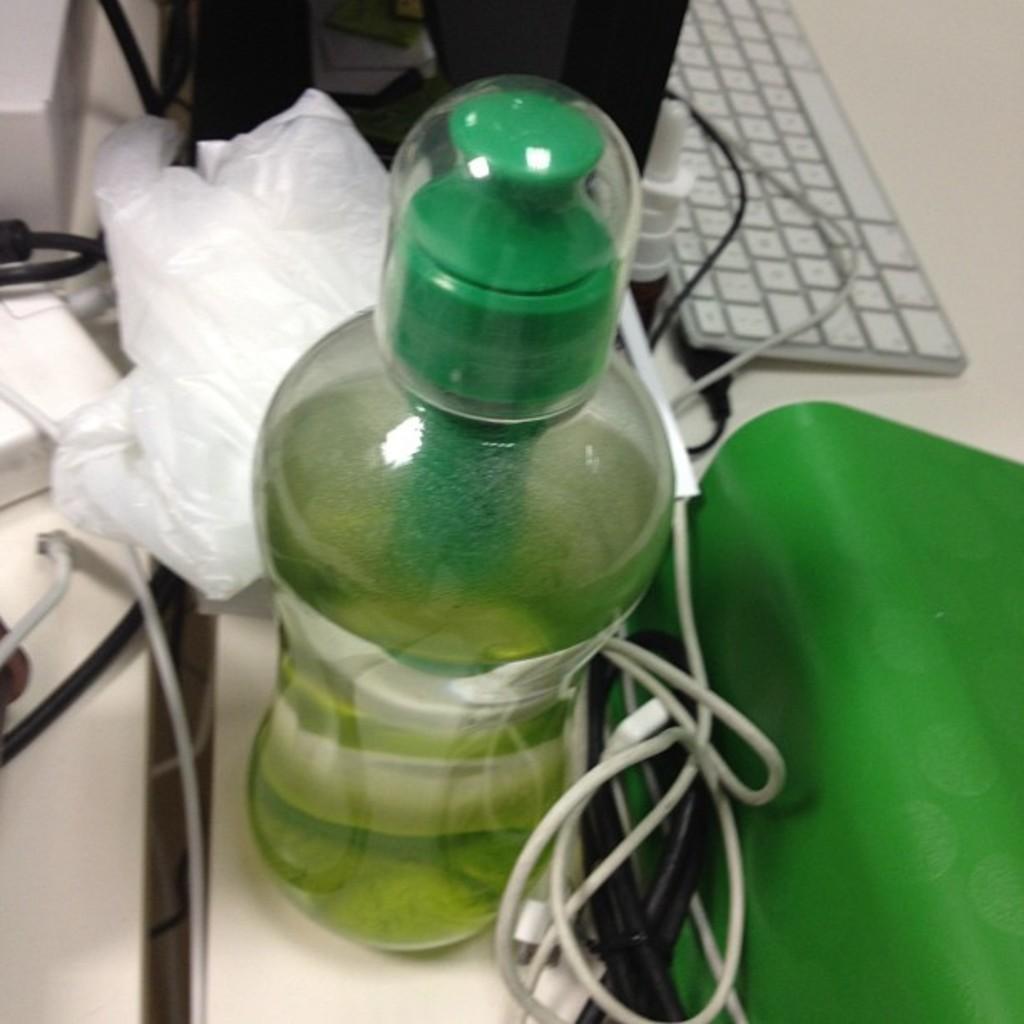Please provide a concise description of this image. here we can see that a bottle on the table, and keyboard and wire and some objects on it. 